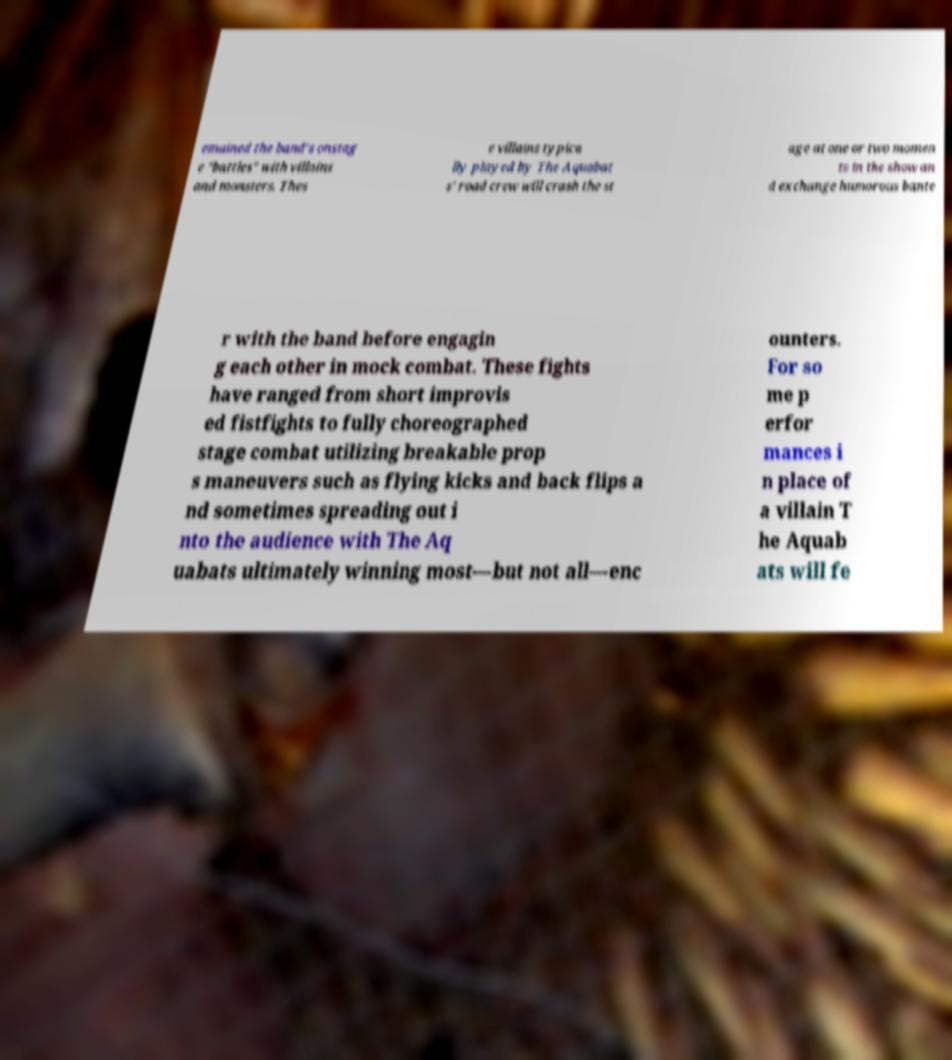Please read and relay the text visible in this image. What does it say? emained the band's onstag e "battles" with villains and monsters. Thes e villains typica lly played by The Aquabat s' road crew will crash the st age at one or two momen ts in the show an d exchange humorous bante r with the band before engagin g each other in mock combat. These fights have ranged from short improvis ed fistfights to fully choreographed stage combat utilizing breakable prop s maneuvers such as flying kicks and back flips a nd sometimes spreading out i nto the audience with The Aq uabats ultimately winning most—but not all—enc ounters. For so me p erfor mances i n place of a villain T he Aquab ats will fe 